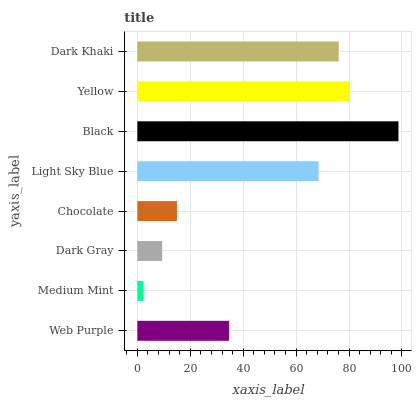Is Medium Mint the minimum?
Answer yes or no. Yes. Is Black the maximum?
Answer yes or no. Yes. Is Dark Gray the minimum?
Answer yes or no. No. Is Dark Gray the maximum?
Answer yes or no. No. Is Dark Gray greater than Medium Mint?
Answer yes or no. Yes. Is Medium Mint less than Dark Gray?
Answer yes or no. Yes. Is Medium Mint greater than Dark Gray?
Answer yes or no. No. Is Dark Gray less than Medium Mint?
Answer yes or no. No. Is Light Sky Blue the high median?
Answer yes or no. Yes. Is Web Purple the low median?
Answer yes or no. Yes. Is Web Purple the high median?
Answer yes or no. No. Is Black the low median?
Answer yes or no. No. 